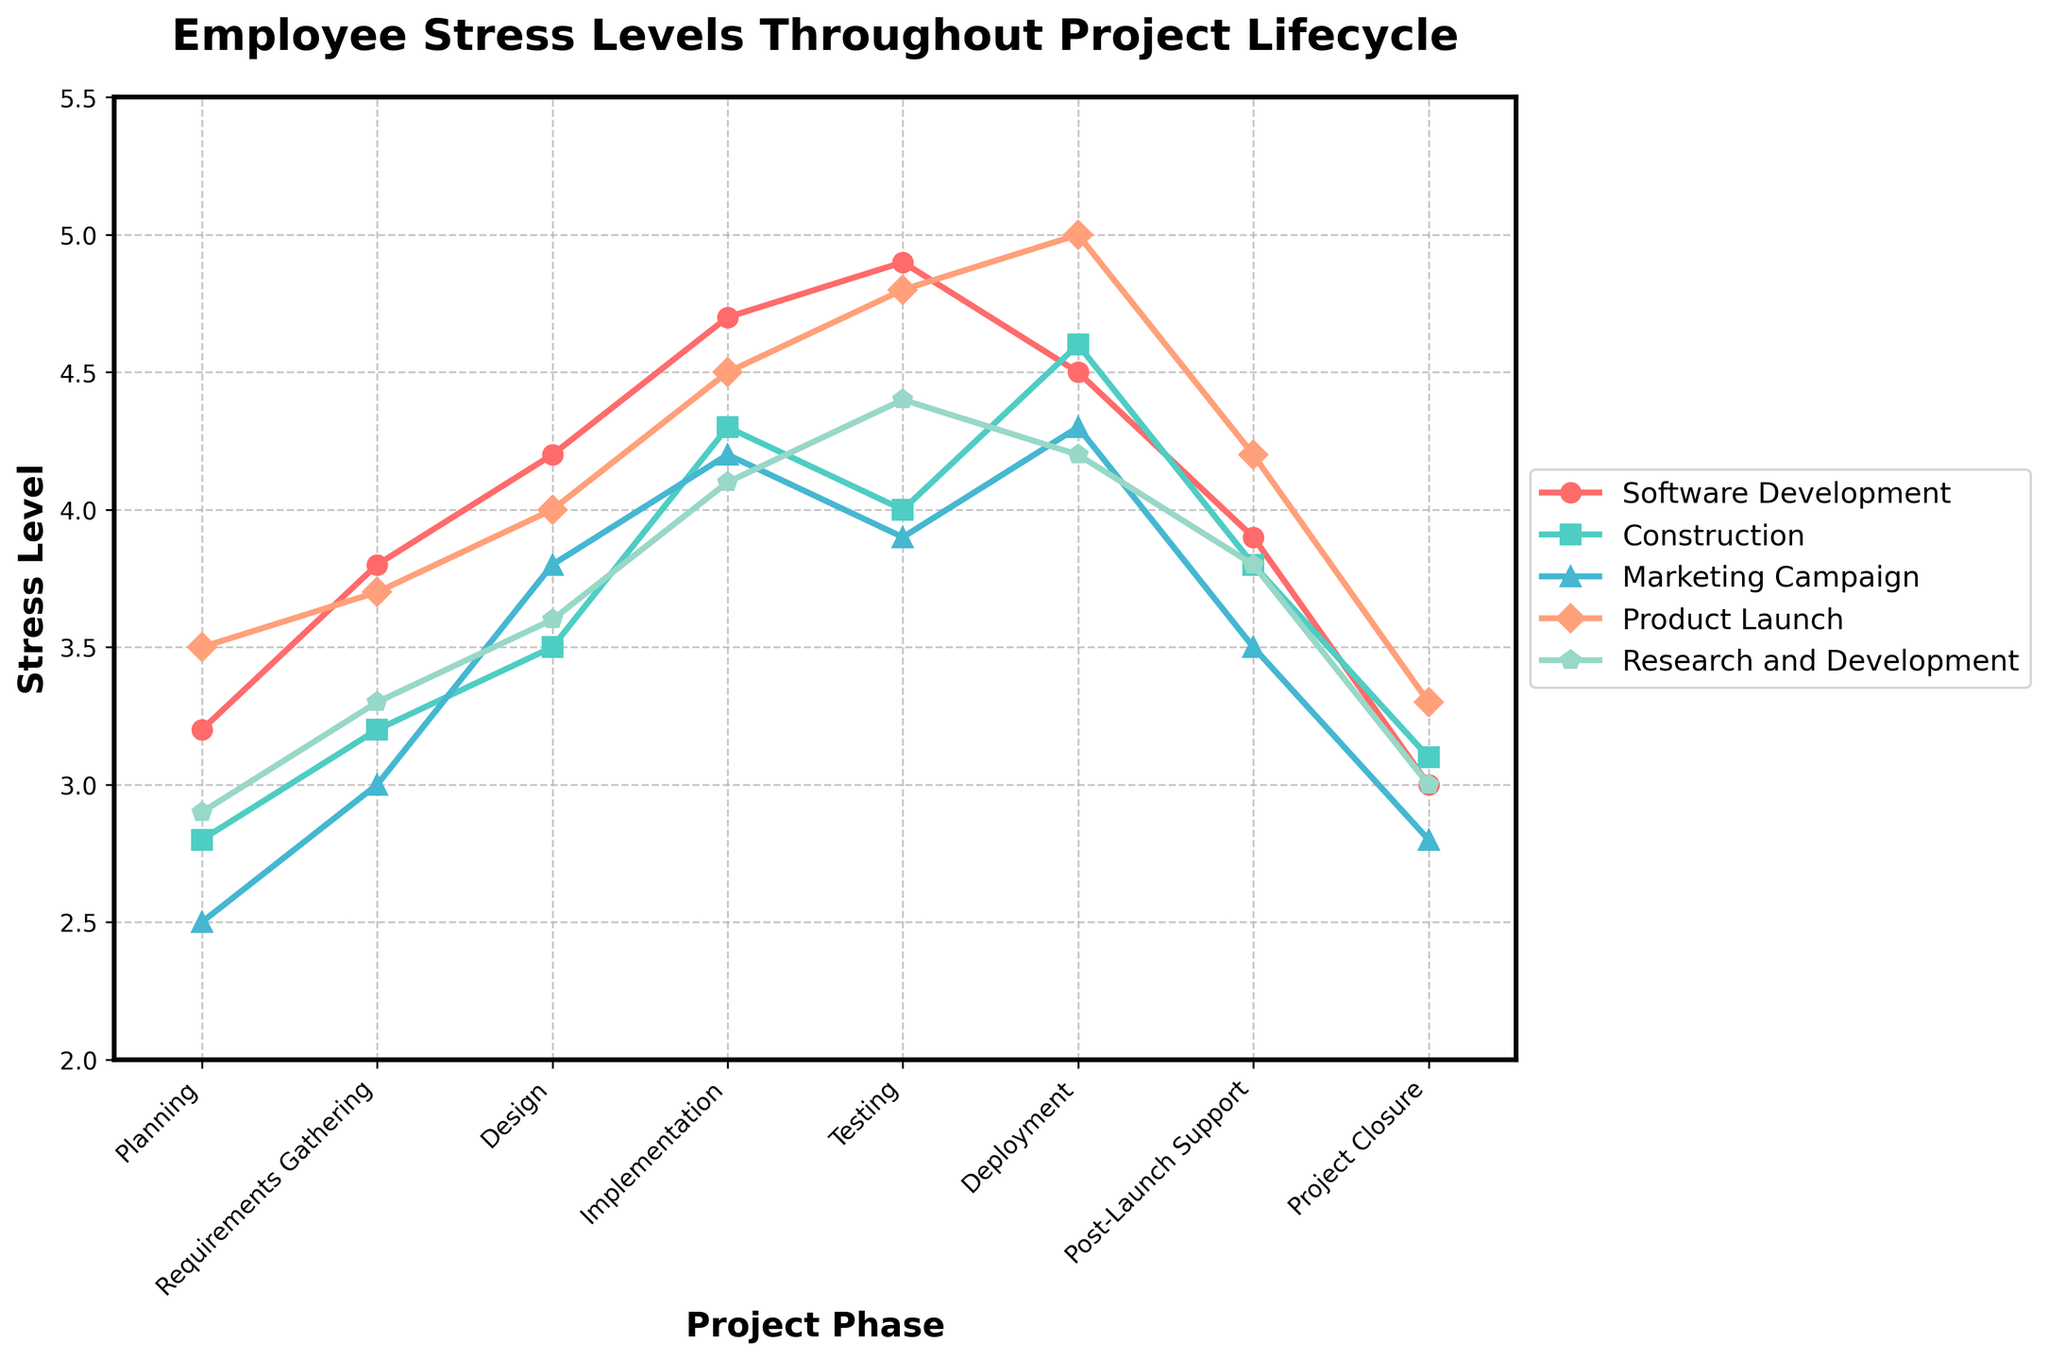What is the highest stress level recorded during the Testing phase? Observing the point where Testing corresponds to the highest stress level, we find it for Software Development at 4.9
Answer: 4.9 Which project type has the lowest stress level during the Planning phase? Checking the lowest value in the Planning phase row, Marketing Campaign has the lowest stress level at 2.5
Answer: Marketing Campaign During which phase does the Product Launch project type experience the highest stress level? Looking through Product Launch data, the highest stress is at Deployment with a value of 5.0
Answer: Deployment How does the stress level change for Construction from Implementation to Project Closure? From Implementation (4.3) to Testing (4.0) to Deployment (4.6) to Post-Launch Support (3.8) to Project Closure (3.1), Construction stress levels first decrease, then increase, then decrease again
Answer: Decrease, increase, decrease Which two project types have the closest stress levels during the Deployment phase, and what are those levels? The two closest values in Deployment are for Software Development (4.5) and Research and Development (4.2)
Answer: Software Development: 4.5, Research and Development: 4.2 Is there any project type where the stress level remains above 4.0 during all phases? Checking all phases for each project type, there is no single project type where stress levels stay above 4 during all phases
Answer: No What is the difference between the maximum and minimum stress levels for the Software Development project type? For Software Development, the range is from 3.0 (Project Closure) to 4.9 (Testing), so the difference is 4.9 - 3.0
Answer: 1.9 What is the average stress level during the Requirements Gathering phase across all project types? Summing up the values: 3.8 (Software Development) + 3.2 (Construction) + 3.0 (Marketing Campaign) + 3.7 (Product Launch) + 3.3 (Research and Development), the average is (3.8 + 3.2 + 3.0 + 3.7 + 3.3) / 5 = 3.4
Answer: 3.4 In the Testing phase, which project types have their stress levels higher than 4.0, and what are the levels? Observing the Testing phase, Software Development (4.9), Product Launch (4.8), and Research and Development (4.4) are higher than 4.0
Answer: Software Development: 4.9, Product Launch: 4.8, Research and Development: 4.4 